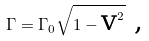<formula> <loc_0><loc_0><loc_500><loc_500>\Gamma = \Gamma _ { 0 } \sqrt { 1 - \text {v} ^ { 2 } } \text { ,}</formula> 